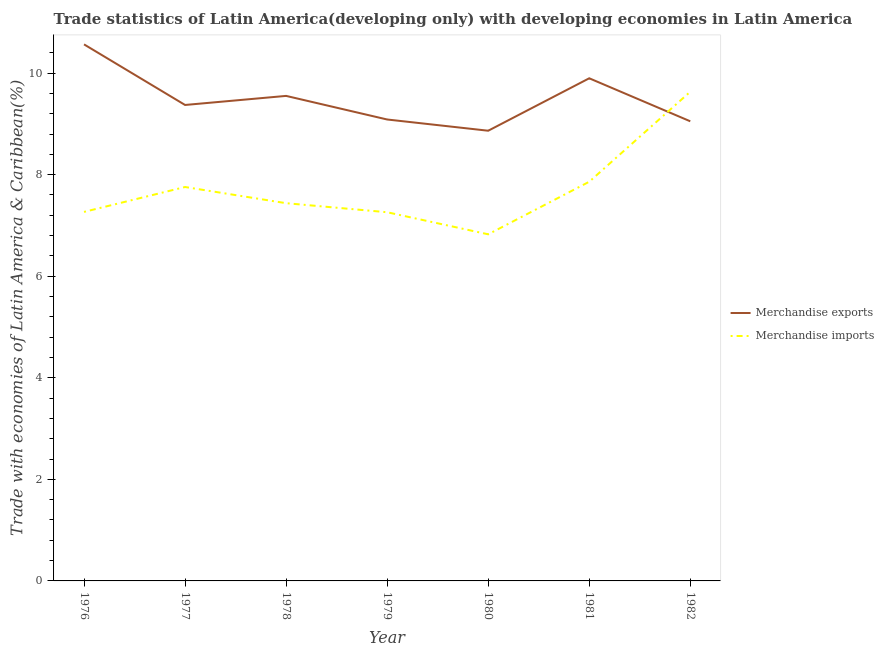How many different coloured lines are there?
Make the answer very short. 2. Is the number of lines equal to the number of legend labels?
Provide a succinct answer. Yes. What is the merchandise imports in 1977?
Provide a short and direct response. 7.76. Across all years, what is the maximum merchandise imports?
Provide a succinct answer. 9.63. Across all years, what is the minimum merchandise imports?
Offer a terse response. 6.82. What is the total merchandise exports in the graph?
Your answer should be compact. 66.38. What is the difference between the merchandise imports in 1976 and that in 1980?
Give a very brief answer. 0.44. What is the difference between the merchandise exports in 1981 and the merchandise imports in 1978?
Ensure brevity in your answer.  2.46. What is the average merchandise exports per year?
Provide a short and direct response. 9.48. In the year 1982, what is the difference between the merchandise imports and merchandise exports?
Offer a very short reply. 0.58. In how many years, is the merchandise imports greater than 8 %?
Provide a succinct answer. 1. What is the ratio of the merchandise imports in 1976 to that in 1980?
Provide a short and direct response. 1.06. What is the difference between the highest and the second highest merchandise imports?
Your answer should be very brief. 1.77. What is the difference between the highest and the lowest merchandise imports?
Ensure brevity in your answer.  2.81. In how many years, is the merchandise exports greater than the average merchandise exports taken over all years?
Provide a short and direct response. 3. Does the merchandise imports monotonically increase over the years?
Ensure brevity in your answer.  No. Is the merchandise imports strictly greater than the merchandise exports over the years?
Provide a short and direct response. No. What is the difference between two consecutive major ticks on the Y-axis?
Your answer should be very brief. 2. Are the values on the major ticks of Y-axis written in scientific E-notation?
Offer a terse response. No. Does the graph contain any zero values?
Offer a very short reply. No. Where does the legend appear in the graph?
Provide a short and direct response. Center right. How many legend labels are there?
Provide a short and direct response. 2. How are the legend labels stacked?
Your response must be concise. Vertical. What is the title of the graph?
Offer a very short reply. Trade statistics of Latin America(developing only) with developing economies in Latin America. What is the label or title of the X-axis?
Your answer should be compact. Year. What is the label or title of the Y-axis?
Offer a terse response. Trade with economies of Latin America & Caribbean(%). What is the Trade with economies of Latin America & Caribbean(%) in Merchandise exports in 1976?
Offer a terse response. 10.56. What is the Trade with economies of Latin America & Caribbean(%) in Merchandise imports in 1976?
Ensure brevity in your answer.  7.27. What is the Trade with economies of Latin America & Caribbean(%) in Merchandise exports in 1977?
Your answer should be very brief. 9.37. What is the Trade with economies of Latin America & Caribbean(%) of Merchandise imports in 1977?
Offer a very short reply. 7.76. What is the Trade with economies of Latin America & Caribbean(%) in Merchandise exports in 1978?
Provide a short and direct response. 9.55. What is the Trade with economies of Latin America & Caribbean(%) in Merchandise imports in 1978?
Your answer should be very brief. 7.44. What is the Trade with economies of Latin America & Caribbean(%) of Merchandise exports in 1979?
Offer a terse response. 9.09. What is the Trade with economies of Latin America & Caribbean(%) in Merchandise imports in 1979?
Offer a very short reply. 7.26. What is the Trade with economies of Latin America & Caribbean(%) of Merchandise exports in 1980?
Your answer should be very brief. 8.86. What is the Trade with economies of Latin America & Caribbean(%) of Merchandise imports in 1980?
Provide a short and direct response. 6.82. What is the Trade with economies of Latin America & Caribbean(%) of Merchandise exports in 1981?
Offer a very short reply. 9.9. What is the Trade with economies of Latin America & Caribbean(%) in Merchandise imports in 1981?
Provide a succinct answer. 7.86. What is the Trade with economies of Latin America & Caribbean(%) of Merchandise exports in 1982?
Give a very brief answer. 9.05. What is the Trade with economies of Latin America & Caribbean(%) in Merchandise imports in 1982?
Your response must be concise. 9.63. Across all years, what is the maximum Trade with economies of Latin America & Caribbean(%) in Merchandise exports?
Provide a succinct answer. 10.56. Across all years, what is the maximum Trade with economies of Latin America & Caribbean(%) in Merchandise imports?
Ensure brevity in your answer.  9.63. Across all years, what is the minimum Trade with economies of Latin America & Caribbean(%) of Merchandise exports?
Offer a terse response. 8.86. Across all years, what is the minimum Trade with economies of Latin America & Caribbean(%) of Merchandise imports?
Your answer should be very brief. 6.82. What is the total Trade with economies of Latin America & Caribbean(%) of Merchandise exports in the graph?
Ensure brevity in your answer.  66.38. What is the total Trade with economies of Latin America & Caribbean(%) in Merchandise imports in the graph?
Offer a terse response. 54.04. What is the difference between the Trade with economies of Latin America & Caribbean(%) in Merchandise exports in 1976 and that in 1977?
Offer a terse response. 1.19. What is the difference between the Trade with economies of Latin America & Caribbean(%) in Merchandise imports in 1976 and that in 1977?
Provide a short and direct response. -0.49. What is the difference between the Trade with economies of Latin America & Caribbean(%) in Merchandise exports in 1976 and that in 1978?
Ensure brevity in your answer.  1.01. What is the difference between the Trade with economies of Latin America & Caribbean(%) in Merchandise imports in 1976 and that in 1978?
Offer a terse response. -0.17. What is the difference between the Trade with economies of Latin America & Caribbean(%) in Merchandise exports in 1976 and that in 1979?
Your answer should be compact. 1.48. What is the difference between the Trade with economies of Latin America & Caribbean(%) of Merchandise imports in 1976 and that in 1979?
Offer a very short reply. 0.01. What is the difference between the Trade with economies of Latin America & Caribbean(%) of Merchandise exports in 1976 and that in 1980?
Your answer should be compact. 1.7. What is the difference between the Trade with economies of Latin America & Caribbean(%) of Merchandise imports in 1976 and that in 1980?
Provide a short and direct response. 0.44. What is the difference between the Trade with economies of Latin America & Caribbean(%) in Merchandise exports in 1976 and that in 1981?
Provide a succinct answer. 0.67. What is the difference between the Trade with economies of Latin America & Caribbean(%) of Merchandise imports in 1976 and that in 1981?
Make the answer very short. -0.59. What is the difference between the Trade with economies of Latin America & Caribbean(%) of Merchandise exports in 1976 and that in 1982?
Your answer should be very brief. 1.51. What is the difference between the Trade with economies of Latin America & Caribbean(%) in Merchandise imports in 1976 and that in 1982?
Provide a succinct answer. -2.37. What is the difference between the Trade with economies of Latin America & Caribbean(%) of Merchandise exports in 1977 and that in 1978?
Offer a terse response. -0.18. What is the difference between the Trade with economies of Latin America & Caribbean(%) of Merchandise imports in 1977 and that in 1978?
Keep it short and to the point. 0.32. What is the difference between the Trade with economies of Latin America & Caribbean(%) of Merchandise exports in 1977 and that in 1979?
Provide a succinct answer. 0.29. What is the difference between the Trade with economies of Latin America & Caribbean(%) in Merchandise imports in 1977 and that in 1979?
Provide a succinct answer. 0.5. What is the difference between the Trade with economies of Latin America & Caribbean(%) in Merchandise exports in 1977 and that in 1980?
Provide a succinct answer. 0.51. What is the difference between the Trade with economies of Latin America & Caribbean(%) in Merchandise imports in 1977 and that in 1980?
Offer a terse response. 0.93. What is the difference between the Trade with economies of Latin America & Caribbean(%) in Merchandise exports in 1977 and that in 1981?
Keep it short and to the point. -0.53. What is the difference between the Trade with economies of Latin America & Caribbean(%) of Merchandise imports in 1977 and that in 1981?
Offer a terse response. -0.1. What is the difference between the Trade with economies of Latin America & Caribbean(%) of Merchandise exports in 1977 and that in 1982?
Give a very brief answer. 0.32. What is the difference between the Trade with economies of Latin America & Caribbean(%) of Merchandise imports in 1977 and that in 1982?
Give a very brief answer. -1.88. What is the difference between the Trade with economies of Latin America & Caribbean(%) in Merchandise exports in 1978 and that in 1979?
Provide a short and direct response. 0.46. What is the difference between the Trade with economies of Latin America & Caribbean(%) in Merchandise imports in 1978 and that in 1979?
Give a very brief answer. 0.18. What is the difference between the Trade with economies of Latin America & Caribbean(%) of Merchandise exports in 1978 and that in 1980?
Provide a succinct answer. 0.69. What is the difference between the Trade with economies of Latin America & Caribbean(%) in Merchandise imports in 1978 and that in 1980?
Offer a terse response. 0.61. What is the difference between the Trade with economies of Latin America & Caribbean(%) in Merchandise exports in 1978 and that in 1981?
Your response must be concise. -0.35. What is the difference between the Trade with economies of Latin America & Caribbean(%) in Merchandise imports in 1978 and that in 1981?
Your response must be concise. -0.42. What is the difference between the Trade with economies of Latin America & Caribbean(%) in Merchandise imports in 1978 and that in 1982?
Provide a short and direct response. -2.19. What is the difference between the Trade with economies of Latin America & Caribbean(%) of Merchandise exports in 1979 and that in 1980?
Keep it short and to the point. 0.22. What is the difference between the Trade with economies of Latin America & Caribbean(%) of Merchandise imports in 1979 and that in 1980?
Keep it short and to the point. 0.43. What is the difference between the Trade with economies of Latin America & Caribbean(%) in Merchandise exports in 1979 and that in 1981?
Your answer should be compact. -0.81. What is the difference between the Trade with economies of Latin America & Caribbean(%) of Merchandise imports in 1979 and that in 1981?
Your answer should be compact. -0.6. What is the difference between the Trade with economies of Latin America & Caribbean(%) in Merchandise exports in 1979 and that in 1982?
Your answer should be very brief. 0.04. What is the difference between the Trade with economies of Latin America & Caribbean(%) in Merchandise imports in 1979 and that in 1982?
Your answer should be very brief. -2.37. What is the difference between the Trade with economies of Latin America & Caribbean(%) of Merchandise exports in 1980 and that in 1981?
Offer a very short reply. -1.03. What is the difference between the Trade with economies of Latin America & Caribbean(%) of Merchandise imports in 1980 and that in 1981?
Offer a very short reply. -1.04. What is the difference between the Trade with economies of Latin America & Caribbean(%) of Merchandise exports in 1980 and that in 1982?
Give a very brief answer. -0.19. What is the difference between the Trade with economies of Latin America & Caribbean(%) in Merchandise imports in 1980 and that in 1982?
Offer a very short reply. -2.81. What is the difference between the Trade with economies of Latin America & Caribbean(%) in Merchandise exports in 1981 and that in 1982?
Keep it short and to the point. 0.85. What is the difference between the Trade with economies of Latin America & Caribbean(%) in Merchandise imports in 1981 and that in 1982?
Ensure brevity in your answer.  -1.77. What is the difference between the Trade with economies of Latin America & Caribbean(%) of Merchandise exports in 1976 and the Trade with economies of Latin America & Caribbean(%) of Merchandise imports in 1977?
Give a very brief answer. 2.81. What is the difference between the Trade with economies of Latin America & Caribbean(%) in Merchandise exports in 1976 and the Trade with economies of Latin America & Caribbean(%) in Merchandise imports in 1978?
Make the answer very short. 3.13. What is the difference between the Trade with economies of Latin America & Caribbean(%) in Merchandise exports in 1976 and the Trade with economies of Latin America & Caribbean(%) in Merchandise imports in 1979?
Your response must be concise. 3.31. What is the difference between the Trade with economies of Latin America & Caribbean(%) of Merchandise exports in 1976 and the Trade with economies of Latin America & Caribbean(%) of Merchandise imports in 1980?
Keep it short and to the point. 3.74. What is the difference between the Trade with economies of Latin America & Caribbean(%) of Merchandise exports in 1976 and the Trade with economies of Latin America & Caribbean(%) of Merchandise imports in 1981?
Make the answer very short. 2.7. What is the difference between the Trade with economies of Latin America & Caribbean(%) in Merchandise exports in 1976 and the Trade with economies of Latin America & Caribbean(%) in Merchandise imports in 1982?
Make the answer very short. 0.93. What is the difference between the Trade with economies of Latin America & Caribbean(%) in Merchandise exports in 1977 and the Trade with economies of Latin America & Caribbean(%) in Merchandise imports in 1978?
Make the answer very short. 1.93. What is the difference between the Trade with economies of Latin America & Caribbean(%) in Merchandise exports in 1977 and the Trade with economies of Latin America & Caribbean(%) in Merchandise imports in 1979?
Provide a short and direct response. 2.11. What is the difference between the Trade with economies of Latin America & Caribbean(%) in Merchandise exports in 1977 and the Trade with economies of Latin America & Caribbean(%) in Merchandise imports in 1980?
Offer a terse response. 2.55. What is the difference between the Trade with economies of Latin America & Caribbean(%) in Merchandise exports in 1977 and the Trade with economies of Latin America & Caribbean(%) in Merchandise imports in 1981?
Offer a terse response. 1.51. What is the difference between the Trade with economies of Latin America & Caribbean(%) of Merchandise exports in 1977 and the Trade with economies of Latin America & Caribbean(%) of Merchandise imports in 1982?
Make the answer very short. -0.26. What is the difference between the Trade with economies of Latin America & Caribbean(%) of Merchandise exports in 1978 and the Trade with economies of Latin America & Caribbean(%) of Merchandise imports in 1979?
Provide a short and direct response. 2.29. What is the difference between the Trade with economies of Latin America & Caribbean(%) in Merchandise exports in 1978 and the Trade with economies of Latin America & Caribbean(%) in Merchandise imports in 1980?
Your response must be concise. 2.73. What is the difference between the Trade with economies of Latin America & Caribbean(%) in Merchandise exports in 1978 and the Trade with economies of Latin America & Caribbean(%) in Merchandise imports in 1981?
Your answer should be compact. 1.69. What is the difference between the Trade with economies of Latin America & Caribbean(%) of Merchandise exports in 1978 and the Trade with economies of Latin America & Caribbean(%) of Merchandise imports in 1982?
Offer a terse response. -0.08. What is the difference between the Trade with economies of Latin America & Caribbean(%) of Merchandise exports in 1979 and the Trade with economies of Latin America & Caribbean(%) of Merchandise imports in 1980?
Ensure brevity in your answer.  2.26. What is the difference between the Trade with economies of Latin America & Caribbean(%) in Merchandise exports in 1979 and the Trade with economies of Latin America & Caribbean(%) in Merchandise imports in 1981?
Your response must be concise. 1.23. What is the difference between the Trade with economies of Latin America & Caribbean(%) in Merchandise exports in 1979 and the Trade with economies of Latin America & Caribbean(%) in Merchandise imports in 1982?
Your response must be concise. -0.55. What is the difference between the Trade with economies of Latin America & Caribbean(%) in Merchandise exports in 1980 and the Trade with economies of Latin America & Caribbean(%) in Merchandise imports in 1981?
Give a very brief answer. 1. What is the difference between the Trade with economies of Latin America & Caribbean(%) of Merchandise exports in 1980 and the Trade with economies of Latin America & Caribbean(%) of Merchandise imports in 1982?
Your answer should be compact. -0.77. What is the difference between the Trade with economies of Latin America & Caribbean(%) of Merchandise exports in 1981 and the Trade with economies of Latin America & Caribbean(%) of Merchandise imports in 1982?
Provide a succinct answer. 0.26. What is the average Trade with economies of Latin America & Caribbean(%) of Merchandise exports per year?
Your answer should be compact. 9.48. What is the average Trade with economies of Latin America & Caribbean(%) of Merchandise imports per year?
Make the answer very short. 7.72. In the year 1976, what is the difference between the Trade with economies of Latin America & Caribbean(%) in Merchandise exports and Trade with economies of Latin America & Caribbean(%) in Merchandise imports?
Ensure brevity in your answer.  3.3. In the year 1977, what is the difference between the Trade with economies of Latin America & Caribbean(%) in Merchandise exports and Trade with economies of Latin America & Caribbean(%) in Merchandise imports?
Your answer should be compact. 1.62. In the year 1978, what is the difference between the Trade with economies of Latin America & Caribbean(%) in Merchandise exports and Trade with economies of Latin America & Caribbean(%) in Merchandise imports?
Keep it short and to the point. 2.11. In the year 1979, what is the difference between the Trade with economies of Latin America & Caribbean(%) of Merchandise exports and Trade with economies of Latin America & Caribbean(%) of Merchandise imports?
Provide a short and direct response. 1.83. In the year 1980, what is the difference between the Trade with economies of Latin America & Caribbean(%) of Merchandise exports and Trade with economies of Latin America & Caribbean(%) of Merchandise imports?
Ensure brevity in your answer.  2.04. In the year 1981, what is the difference between the Trade with economies of Latin America & Caribbean(%) of Merchandise exports and Trade with economies of Latin America & Caribbean(%) of Merchandise imports?
Your answer should be very brief. 2.04. In the year 1982, what is the difference between the Trade with economies of Latin America & Caribbean(%) of Merchandise exports and Trade with economies of Latin America & Caribbean(%) of Merchandise imports?
Your response must be concise. -0.58. What is the ratio of the Trade with economies of Latin America & Caribbean(%) of Merchandise exports in 1976 to that in 1977?
Provide a short and direct response. 1.13. What is the ratio of the Trade with economies of Latin America & Caribbean(%) of Merchandise imports in 1976 to that in 1977?
Provide a succinct answer. 0.94. What is the ratio of the Trade with economies of Latin America & Caribbean(%) of Merchandise exports in 1976 to that in 1978?
Provide a short and direct response. 1.11. What is the ratio of the Trade with economies of Latin America & Caribbean(%) in Merchandise imports in 1976 to that in 1978?
Give a very brief answer. 0.98. What is the ratio of the Trade with economies of Latin America & Caribbean(%) of Merchandise exports in 1976 to that in 1979?
Offer a terse response. 1.16. What is the ratio of the Trade with economies of Latin America & Caribbean(%) in Merchandise exports in 1976 to that in 1980?
Your answer should be very brief. 1.19. What is the ratio of the Trade with economies of Latin America & Caribbean(%) in Merchandise imports in 1976 to that in 1980?
Provide a succinct answer. 1.06. What is the ratio of the Trade with economies of Latin America & Caribbean(%) in Merchandise exports in 1976 to that in 1981?
Your answer should be very brief. 1.07. What is the ratio of the Trade with economies of Latin America & Caribbean(%) of Merchandise imports in 1976 to that in 1981?
Offer a terse response. 0.92. What is the ratio of the Trade with economies of Latin America & Caribbean(%) of Merchandise exports in 1976 to that in 1982?
Offer a terse response. 1.17. What is the ratio of the Trade with economies of Latin America & Caribbean(%) of Merchandise imports in 1976 to that in 1982?
Provide a succinct answer. 0.75. What is the ratio of the Trade with economies of Latin America & Caribbean(%) in Merchandise exports in 1977 to that in 1978?
Offer a very short reply. 0.98. What is the ratio of the Trade with economies of Latin America & Caribbean(%) in Merchandise imports in 1977 to that in 1978?
Your response must be concise. 1.04. What is the ratio of the Trade with economies of Latin America & Caribbean(%) in Merchandise exports in 1977 to that in 1979?
Make the answer very short. 1.03. What is the ratio of the Trade with economies of Latin America & Caribbean(%) in Merchandise imports in 1977 to that in 1979?
Your response must be concise. 1.07. What is the ratio of the Trade with economies of Latin America & Caribbean(%) of Merchandise exports in 1977 to that in 1980?
Give a very brief answer. 1.06. What is the ratio of the Trade with economies of Latin America & Caribbean(%) in Merchandise imports in 1977 to that in 1980?
Provide a succinct answer. 1.14. What is the ratio of the Trade with economies of Latin America & Caribbean(%) in Merchandise exports in 1977 to that in 1981?
Ensure brevity in your answer.  0.95. What is the ratio of the Trade with economies of Latin America & Caribbean(%) of Merchandise exports in 1977 to that in 1982?
Offer a very short reply. 1.04. What is the ratio of the Trade with economies of Latin America & Caribbean(%) in Merchandise imports in 1977 to that in 1982?
Your response must be concise. 0.81. What is the ratio of the Trade with economies of Latin America & Caribbean(%) in Merchandise exports in 1978 to that in 1979?
Your answer should be compact. 1.05. What is the ratio of the Trade with economies of Latin America & Caribbean(%) in Merchandise imports in 1978 to that in 1979?
Keep it short and to the point. 1.02. What is the ratio of the Trade with economies of Latin America & Caribbean(%) in Merchandise exports in 1978 to that in 1980?
Ensure brevity in your answer.  1.08. What is the ratio of the Trade with economies of Latin America & Caribbean(%) of Merchandise imports in 1978 to that in 1980?
Your answer should be very brief. 1.09. What is the ratio of the Trade with economies of Latin America & Caribbean(%) of Merchandise exports in 1978 to that in 1981?
Offer a terse response. 0.96. What is the ratio of the Trade with economies of Latin America & Caribbean(%) in Merchandise imports in 1978 to that in 1981?
Your answer should be very brief. 0.95. What is the ratio of the Trade with economies of Latin America & Caribbean(%) in Merchandise exports in 1978 to that in 1982?
Provide a short and direct response. 1.06. What is the ratio of the Trade with economies of Latin America & Caribbean(%) of Merchandise imports in 1978 to that in 1982?
Your answer should be very brief. 0.77. What is the ratio of the Trade with economies of Latin America & Caribbean(%) in Merchandise imports in 1979 to that in 1980?
Offer a very short reply. 1.06. What is the ratio of the Trade with economies of Latin America & Caribbean(%) in Merchandise exports in 1979 to that in 1981?
Provide a short and direct response. 0.92. What is the ratio of the Trade with economies of Latin America & Caribbean(%) of Merchandise imports in 1979 to that in 1981?
Your response must be concise. 0.92. What is the ratio of the Trade with economies of Latin America & Caribbean(%) of Merchandise exports in 1979 to that in 1982?
Offer a very short reply. 1. What is the ratio of the Trade with economies of Latin America & Caribbean(%) of Merchandise imports in 1979 to that in 1982?
Offer a terse response. 0.75. What is the ratio of the Trade with economies of Latin America & Caribbean(%) in Merchandise exports in 1980 to that in 1981?
Ensure brevity in your answer.  0.9. What is the ratio of the Trade with economies of Latin America & Caribbean(%) of Merchandise imports in 1980 to that in 1981?
Offer a very short reply. 0.87. What is the ratio of the Trade with economies of Latin America & Caribbean(%) in Merchandise exports in 1980 to that in 1982?
Offer a terse response. 0.98. What is the ratio of the Trade with economies of Latin America & Caribbean(%) in Merchandise imports in 1980 to that in 1982?
Your answer should be compact. 0.71. What is the ratio of the Trade with economies of Latin America & Caribbean(%) of Merchandise exports in 1981 to that in 1982?
Your answer should be compact. 1.09. What is the ratio of the Trade with economies of Latin America & Caribbean(%) of Merchandise imports in 1981 to that in 1982?
Keep it short and to the point. 0.82. What is the difference between the highest and the second highest Trade with economies of Latin America & Caribbean(%) of Merchandise exports?
Provide a short and direct response. 0.67. What is the difference between the highest and the second highest Trade with economies of Latin America & Caribbean(%) in Merchandise imports?
Offer a terse response. 1.77. What is the difference between the highest and the lowest Trade with economies of Latin America & Caribbean(%) in Merchandise exports?
Provide a succinct answer. 1.7. What is the difference between the highest and the lowest Trade with economies of Latin America & Caribbean(%) in Merchandise imports?
Your answer should be very brief. 2.81. 